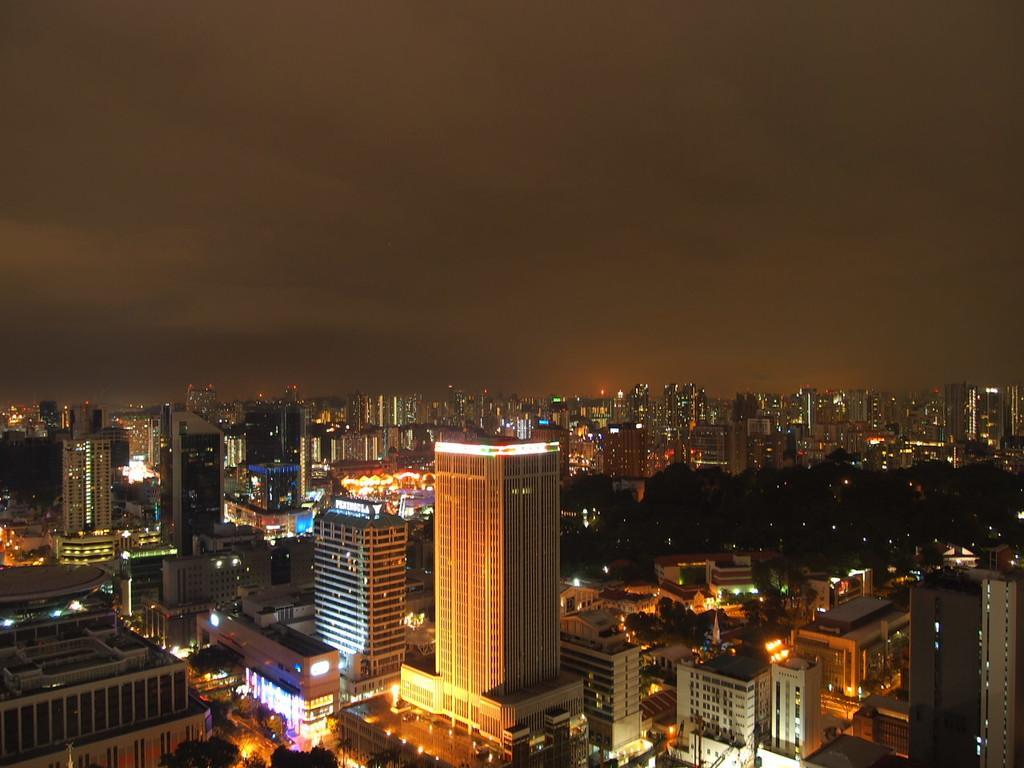What type of structures can be seen in the image? There are multiple buildings in the image. What else is visible in the image besides the buildings? There are lights and the sky visible in the image. What type of natural elements can be seen in the image? There are trees at the bottom of the image. What type of stamp can be seen on the shirt of the person in the image? There is no person or shirt present in the image, so it is not possible to determine if there is a stamp on a shirt. 